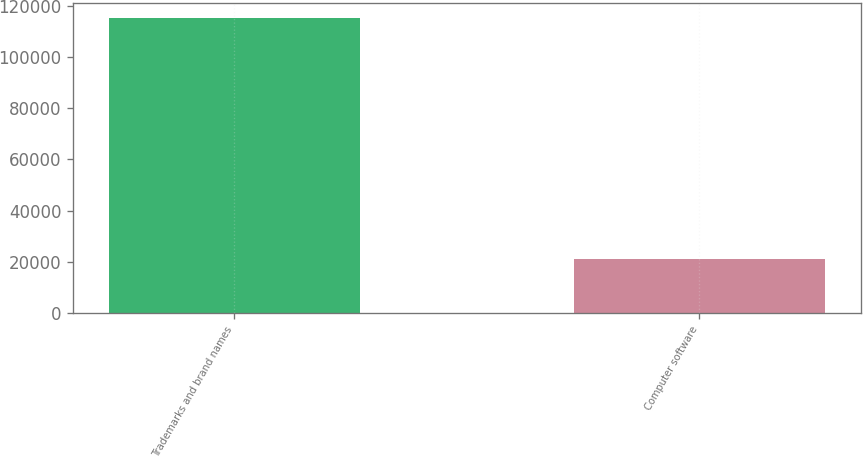Convert chart. <chart><loc_0><loc_0><loc_500><loc_500><bar_chart><fcel>Trademarks and brand names<fcel>Computer software<nl><fcel>115294<fcel>20920<nl></chart> 